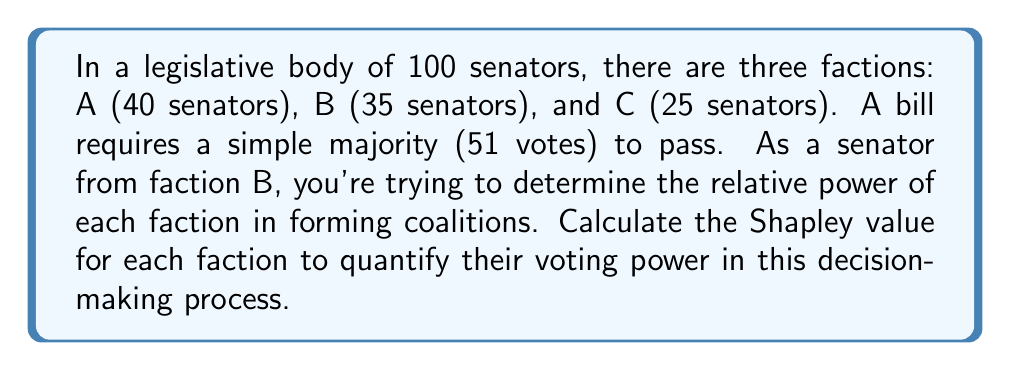Show me your answer to this math problem. To calculate the Shapley value, we need to consider all possible coalitions and the marginal contribution of each faction to these coalitions. Let's follow these steps:

1) First, list all possible coalitions that can form a majority:
   - A + B (75 votes)
   - A + C (65 votes)
   - B + C (60 votes)
   - A + B + C (100 votes)

2) Now, we need to consider all possible orderings of the factions and determine the marginal contribution of each faction in each ordering:

   ABC: A(1), B(0), C(0)
   ACB: A(1), C(0), B(0)
   BAC: B(0), A(1), C(0)
   BCA: B(0), C(0), A(1)
   CAB: C(0), A(1), B(0)
   CBA: C(0), B(0), A(1)

3) Calculate the Shapley value for each faction:

   For A: $\phi_A = \frac{1}{3!}(1 + 1 + 1 + 1 + 1 + 1) = \frac{6}{6} = 1$

   For B: $\phi_B = \frac{1}{3!}(0 + 0 + 0 + 0 + 0 + 0) = 0$

   For C: $\phi_C = \frac{1}{3!}(0 + 0 + 0 + 0 + 0 + 0) = 0$

4) Normalize the Shapley values:

   Total: $1 + 0 + 0 = 1$

   Normalized Shapley values:
   A: $\frac{1}{1} = 1$
   B: $\frac{0}{1} = 0$
   C: $\frac{0}{1} = 0$
Answer: The Shapley values for the factions are:
A: 1 (100%)
B: 0 (0%)
C: 0 (0%)

This indicates that faction A has all the voting power in this scenario, despite not having an outright majority, while factions B and C have no effective voting power in forming coalitions. 